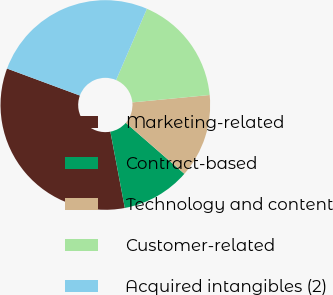Convert chart to OTSL. <chart><loc_0><loc_0><loc_500><loc_500><pie_chart><fcel>Marketing-related<fcel>Contract-based<fcel>Technology and content<fcel>Customer-related<fcel>Acquired intangibles (2)<nl><fcel>33.63%<fcel>10.62%<fcel>12.92%<fcel>16.99%<fcel>25.84%<nl></chart> 